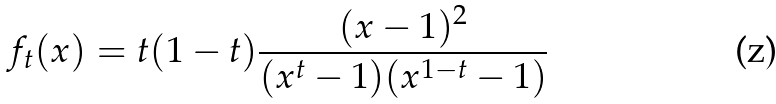<formula> <loc_0><loc_0><loc_500><loc_500>f _ { t } ( x ) = t ( 1 - t ) \frac { ( x - 1 ) ^ { 2 } } { ( x ^ { t } - 1 ) ( x ^ { 1 - t } - 1 ) }</formula> 